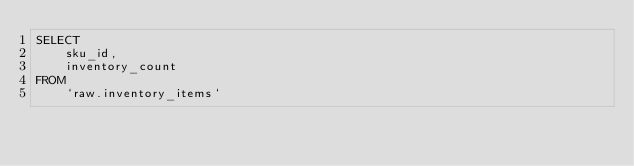Convert code to text. <code><loc_0><loc_0><loc_500><loc_500><_SQL_>SELECT
    sku_id,
    inventory_count
FROM 
    `raw.inventory_items`
</code> 